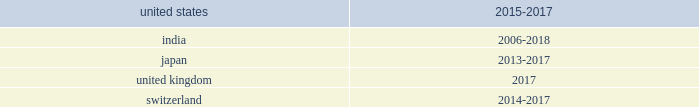The company believes that it is reasonably possible that a decrease of up to $ 8 million in gross unrecognized income tax benefits for federal , state and foreign exposure items may be necessary within the next 12 months due to lapse of statutes of limitations or uncertain tax positions being effectively settled .
The company believes that it is reasonably possible that a decrease of up to $ 14 million in gross unrecognized income tax benefits for foreign items may be necessary within the next 12 months due to payments .
For the remaining uncertain income tax positions , it is difficult at this time to estimate the timing of the resolution .
The company conducts business globally and , as a result , files income tax returns in the united states federal jurisdiction and various state and foreign jurisdictions .
In the normal course of business , the company is subject to examination by taxing authorities throughout the world .
The table summarizes the tax years that remain open for examination by tax authorities in the most significant jurisdictions in which the company operates: .
In certain of the jurisdictions noted above , the company operates through more than one legal entity , each of which has different open years subject to examination .
The table above presents the open years subject to examination for the most material of the legal entities in each jurisdiction .
Additionally , it is important to note that tax years are technically not closed until the statute of limitations in each jurisdiction expires .
In the jurisdictions noted above , the statute of limitations can extend beyond the open years subject to examination .
Due to the geographic breadth of the company 2019s operations , numerous tax audits may be ongoing throughout the world at any point in time .
Income tax liabilities are recorded based on estimates of additional income taxes that may be due upon the conclusion of these audits .
Estimates of these income tax liabilities are made based upon prior experience and are updated in light of changes in facts and circumstances .
However , due to the uncertain and complex application of income tax regulations , it is possible that the ultimate resolution of audits may result in liabilities that could be materially different from these estimates .
In such an event , the company will record additional income tax expense or income tax benefit in the period in which such resolution occurs. .
What is the total value of expected decrease in gross unrecognized income tax benefits in the next 12 months , ( in millions ) ? 
Computations: (8 + 14)
Answer: 22.0. 